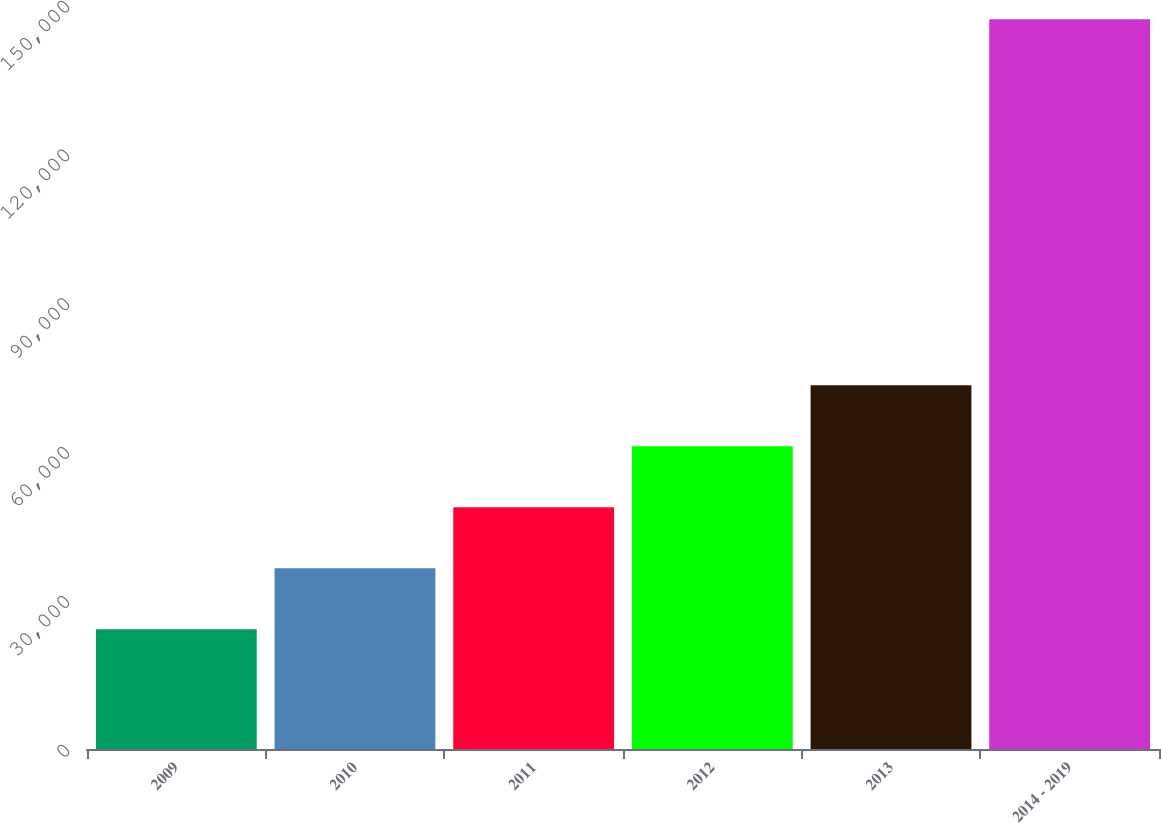Convert chart. <chart><loc_0><loc_0><loc_500><loc_500><bar_chart><fcel>2009<fcel>2010<fcel>2011<fcel>2012<fcel>2013<fcel>2014 - 2019<nl><fcel>24138<fcel>36436.8<fcel>48735.6<fcel>61034.4<fcel>73333.2<fcel>147126<nl></chart> 